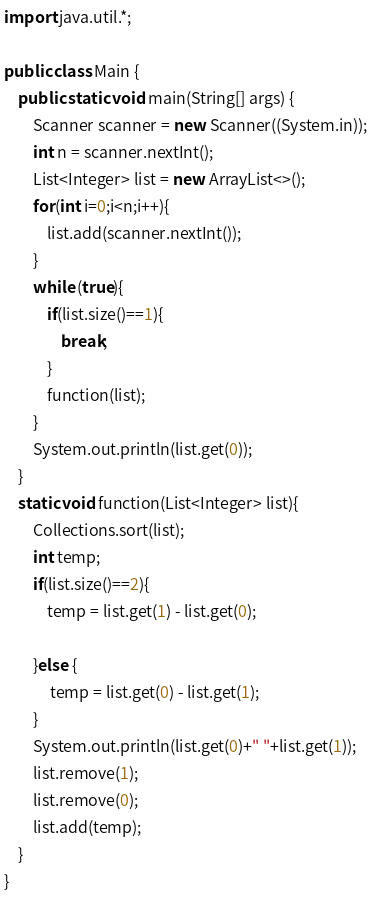Convert code to text. <code><loc_0><loc_0><loc_500><loc_500><_Java_>import java.util.*;

public class Main {
    public static void main(String[] args) {
        Scanner scanner = new Scanner((System.in));
        int n = scanner.nextInt();
        List<Integer> list = new ArrayList<>();
        for(int i=0;i<n;i++){
            list.add(scanner.nextInt());
        }
        while (true){
            if(list.size()==1){
                break;
            }
            function(list);
        }
        System.out.println(list.get(0));
    }
    static void function(List<Integer> list){
        Collections.sort(list);
        int temp;
        if(list.size()==2){
            temp = list.get(1) - list.get(0);

        }else {
             temp = list.get(0) - list.get(1);
        }
        System.out.println(list.get(0)+" "+list.get(1));
        list.remove(1);
        list.remove(0);
        list.add(temp);
    }
}
</code> 